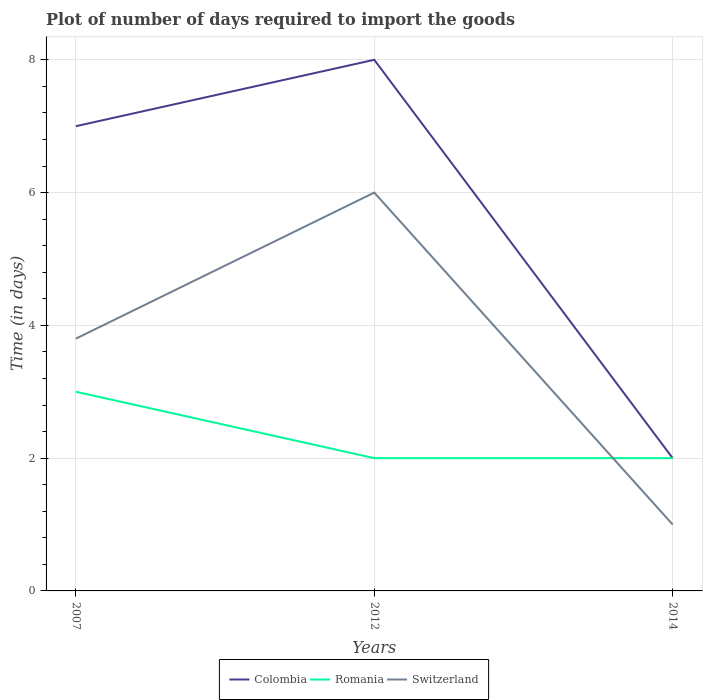How many different coloured lines are there?
Ensure brevity in your answer.  3. Does the line corresponding to Romania intersect with the line corresponding to Colombia?
Keep it short and to the point. Yes. Across all years, what is the maximum time required to import goods in Colombia?
Offer a very short reply. 2. In which year was the time required to import goods in Switzerland maximum?
Offer a very short reply. 2014. What is the total time required to import goods in Romania in the graph?
Offer a very short reply. 1. What is the difference between the highest and the second highest time required to import goods in Romania?
Offer a terse response. 1. What is the difference between the highest and the lowest time required to import goods in Switzerland?
Provide a succinct answer. 2. How many years are there in the graph?
Give a very brief answer. 3. Are the values on the major ticks of Y-axis written in scientific E-notation?
Your answer should be compact. No. Does the graph contain grids?
Keep it short and to the point. Yes. How many legend labels are there?
Make the answer very short. 3. What is the title of the graph?
Make the answer very short. Plot of number of days required to import the goods. What is the label or title of the Y-axis?
Offer a terse response. Time (in days). What is the Time (in days) in Colombia in 2007?
Give a very brief answer. 7. What is the Time (in days) of Colombia in 2012?
Offer a terse response. 8. What is the Time (in days) in Switzerland in 2012?
Your response must be concise. 6. What is the Time (in days) of Romania in 2014?
Make the answer very short. 2. Across all years, what is the maximum Time (in days) of Romania?
Your response must be concise. 3. Across all years, what is the maximum Time (in days) of Switzerland?
Offer a terse response. 6. Across all years, what is the minimum Time (in days) of Colombia?
Your response must be concise. 2. What is the total Time (in days) in Romania in the graph?
Offer a very short reply. 7. What is the total Time (in days) of Switzerland in the graph?
Ensure brevity in your answer.  10.8. What is the difference between the Time (in days) of Switzerland in 2007 and that in 2012?
Make the answer very short. -2.2. What is the difference between the Time (in days) of Romania in 2007 and that in 2014?
Provide a short and direct response. 1. What is the difference between the Time (in days) in Switzerland in 2012 and that in 2014?
Give a very brief answer. 5. What is the difference between the Time (in days) of Colombia in 2007 and the Time (in days) of Romania in 2012?
Offer a terse response. 5. What is the difference between the Time (in days) of Colombia in 2007 and the Time (in days) of Switzerland in 2012?
Provide a short and direct response. 1. What is the difference between the Time (in days) of Colombia in 2007 and the Time (in days) of Romania in 2014?
Provide a succinct answer. 5. What is the difference between the Time (in days) of Romania in 2007 and the Time (in days) of Switzerland in 2014?
Offer a terse response. 2. What is the difference between the Time (in days) in Colombia in 2012 and the Time (in days) in Romania in 2014?
Your response must be concise. 6. What is the average Time (in days) in Colombia per year?
Make the answer very short. 5.67. What is the average Time (in days) of Romania per year?
Your response must be concise. 2.33. What is the average Time (in days) in Switzerland per year?
Make the answer very short. 3.6. In the year 2014, what is the difference between the Time (in days) of Colombia and Time (in days) of Switzerland?
Your answer should be very brief. 1. In the year 2014, what is the difference between the Time (in days) of Romania and Time (in days) of Switzerland?
Your answer should be compact. 1. What is the ratio of the Time (in days) of Romania in 2007 to that in 2012?
Provide a short and direct response. 1.5. What is the ratio of the Time (in days) of Switzerland in 2007 to that in 2012?
Your answer should be very brief. 0.63. What is the difference between the highest and the second highest Time (in days) in Colombia?
Offer a very short reply. 1. What is the difference between the highest and the second highest Time (in days) in Romania?
Ensure brevity in your answer.  1. 